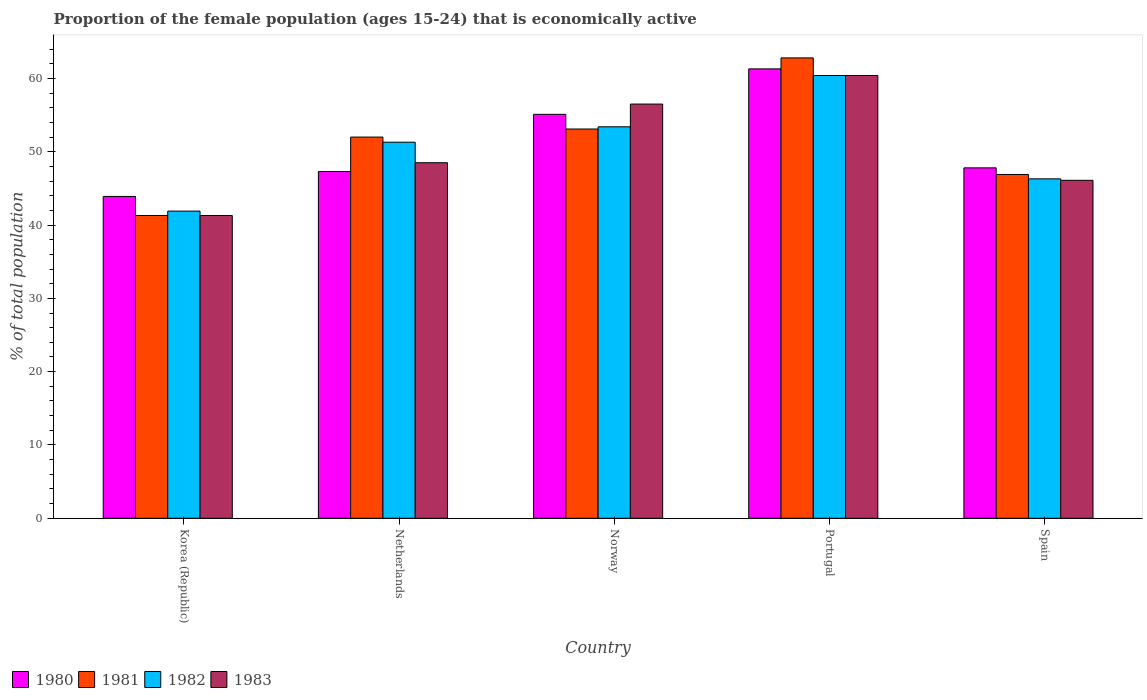How many different coloured bars are there?
Give a very brief answer. 4. Are the number of bars on each tick of the X-axis equal?
Your response must be concise. Yes. How many bars are there on the 2nd tick from the left?
Keep it short and to the point. 4. How many bars are there on the 2nd tick from the right?
Ensure brevity in your answer.  4. What is the label of the 1st group of bars from the left?
Provide a short and direct response. Korea (Republic). What is the proportion of the female population that is economically active in 1980 in Spain?
Your response must be concise. 47.8. Across all countries, what is the maximum proportion of the female population that is economically active in 1981?
Provide a succinct answer. 62.8. Across all countries, what is the minimum proportion of the female population that is economically active in 1980?
Provide a succinct answer. 43.9. In which country was the proportion of the female population that is economically active in 1980 maximum?
Offer a terse response. Portugal. What is the total proportion of the female population that is economically active in 1982 in the graph?
Offer a very short reply. 253.3. What is the difference between the proportion of the female population that is economically active in 1981 in Korea (Republic) and that in Portugal?
Ensure brevity in your answer.  -21.5. What is the difference between the proportion of the female population that is economically active in 1982 in Korea (Republic) and the proportion of the female population that is economically active in 1980 in Spain?
Offer a very short reply. -5.9. What is the average proportion of the female population that is economically active in 1980 per country?
Offer a very short reply. 51.08. What is the ratio of the proportion of the female population that is economically active in 1981 in Netherlands to that in Spain?
Provide a short and direct response. 1.11. Is the proportion of the female population that is economically active in 1982 in Korea (Republic) less than that in Spain?
Offer a terse response. Yes. What is the difference between the highest and the second highest proportion of the female population that is economically active in 1983?
Offer a very short reply. 8. What is the difference between the highest and the lowest proportion of the female population that is economically active in 1980?
Your response must be concise. 17.4. Is the sum of the proportion of the female population that is economically active in 1980 in Portugal and Spain greater than the maximum proportion of the female population that is economically active in 1982 across all countries?
Ensure brevity in your answer.  Yes. Is it the case that in every country, the sum of the proportion of the female population that is economically active in 1981 and proportion of the female population that is economically active in 1982 is greater than the sum of proportion of the female population that is economically active in 1980 and proportion of the female population that is economically active in 1983?
Offer a terse response. No. What does the 2nd bar from the right in Portugal represents?
Your response must be concise. 1982. Is it the case that in every country, the sum of the proportion of the female population that is economically active in 1981 and proportion of the female population that is economically active in 1980 is greater than the proportion of the female population that is economically active in 1983?
Ensure brevity in your answer.  Yes. Are all the bars in the graph horizontal?
Your response must be concise. No. How many countries are there in the graph?
Your response must be concise. 5. Where does the legend appear in the graph?
Provide a succinct answer. Bottom left. How many legend labels are there?
Your answer should be compact. 4. How are the legend labels stacked?
Provide a succinct answer. Horizontal. What is the title of the graph?
Your answer should be compact. Proportion of the female population (ages 15-24) that is economically active. Does "1985" appear as one of the legend labels in the graph?
Give a very brief answer. No. What is the label or title of the X-axis?
Provide a short and direct response. Country. What is the label or title of the Y-axis?
Offer a very short reply. % of total population. What is the % of total population of 1980 in Korea (Republic)?
Make the answer very short. 43.9. What is the % of total population in 1981 in Korea (Republic)?
Keep it short and to the point. 41.3. What is the % of total population in 1982 in Korea (Republic)?
Provide a succinct answer. 41.9. What is the % of total population in 1983 in Korea (Republic)?
Your response must be concise. 41.3. What is the % of total population of 1980 in Netherlands?
Provide a short and direct response. 47.3. What is the % of total population in 1982 in Netherlands?
Provide a succinct answer. 51.3. What is the % of total population in 1983 in Netherlands?
Your answer should be compact. 48.5. What is the % of total population of 1980 in Norway?
Your answer should be compact. 55.1. What is the % of total population in 1981 in Norway?
Ensure brevity in your answer.  53.1. What is the % of total population of 1982 in Norway?
Provide a short and direct response. 53.4. What is the % of total population of 1983 in Norway?
Provide a short and direct response. 56.5. What is the % of total population of 1980 in Portugal?
Ensure brevity in your answer.  61.3. What is the % of total population in 1981 in Portugal?
Your response must be concise. 62.8. What is the % of total population of 1982 in Portugal?
Your response must be concise. 60.4. What is the % of total population in 1983 in Portugal?
Make the answer very short. 60.4. What is the % of total population in 1980 in Spain?
Ensure brevity in your answer.  47.8. What is the % of total population of 1981 in Spain?
Provide a short and direct response. 46.9. What is the % of total population in 1982 in Spain?
Your response must be concise. 46.3. What is the % of total population of 1983 in Spain?
Make the answer very short. 46.1. Across all countries, what is the maximum % of total population in 1980?
Offer a very short reply. 61.3. Across all countries, what is the maximum % of total population in 1981?
Offer a terse response. 62.8. Across all countries, what is the maximum % of total population in 1982?
Give a very brief answer. 60.4. Across all countries, what is the maximum % of total population in 1983?
Ensure brevity in your answer.  60.4. Across all countries, what is the minimum % of total population of 1980?
Your answer should be compact. 43.9. Across all countries, what is the minimum % of total population of 1981?
Your answer should be very brief. 41.3. Across all countries, what is the minimum % of total population of 1982?
Provide a short and direct response. 41.9. Across all countries, what is the minimum % of total population of 1983?
Your answer should be very brief. 41.3. What is the total % of total population in 1980 in the graph?
Your answer should be very brief. 255.4. What is the total % of total population of 1981 in the graph?
Ensure brevity in your answer.  256.1. What is the total % of total population in 1982 in the graph?
Offer a terse response. 253.3. What is the total % of total population in 1983 in the graph?
Offer a very short reply. 252.8. What is the difference between the % of total population of 1982 in Korea (Republic) and that in Netherlands?
Keep it short and to the point. -9.4. What is the difference between the % of total population of 1980 in Korea (Republic) and that in Norway?
Make the answer very short. -11.2. What is the difference between the % of total population of 1981 in Korea (Republic) and that in Norway?
Make the answer very short. -11.8. What is the difference between the % of total population of 1983 in Korea (Republic) and that in Norway?
Offer a terse response. -15.2. What is the difference between the % of total population in 1980 in Korea (Republic) and that in Portugal?
Give a very brief answer. -17.4. What is the difference between the % of total population in 1981 in Korea (Republic) and that in Portugal?
Ensure brevity in your answer.  -21.5. What is the difference between the % of total population of 1982 in Korea (Republic) and that in Portugal?
Keep it short and to the point. -18.5. What is the difference between the % of total population of 1983 in Korea (Republic) and that in Portugal?
Ensure brevity in your answer.  -19.1. What is the difference between the % of total population of 1980 in Korea (Republic) and that in Spain?
Your answer should be very brief. -3.9. What is the difference between the % of total population of 1982 in Korea (Republic) and that in Spain?
Your answer should be compact. -4.4. What is the difference between the % of total population of 1983 in Netherlands and that in Norway?
Your answer should be very brief. -8. What is the difference between the % of total population of 1980 in Netherlands and that in Portugal?
Keep it short and to the point. -14. What is the difference between the % of total population in 1982 in Netherlands and that in Spain?
Provide a succinct answer. 5. What is the difference between the % of total population of 1983 in Netherlands and that in Spain?
Give a very brief answer. 2.4. What is the difference between the % of total population of 1981 in Norway and that in Portugal?
Provide a succinct answer. -9.7. What is the difference between the % of total population of 1982 in Norway and that in Portugal?
Provide a succinct answer. -7. What is the difference between the % of total population in 1983 in Norway and that in Portugal?
Give a very brief answer. -3.9. What is the difference between the % of total population in 1980 in Norway and that in Spain?
Give a very brief answer. 7.3. What is the difference between the % of total population in 1981 in Norway and that in Spain?
Give a very brief answer. 6.2. What is the difference between the % of total population in 1982 in Norway and that in Spain?
Offer a terse response. 7.1. What is the difference between the % of total population of 1983 in Norway and that in Spain?
Offer a terse response. 10.4. What is the difference between the % of total population of 1982 in Portugal and that in Spain?
Your answer should be very brief. 14.1. What is the difference between the % of total population of 1983 in Portugal and that in Spain?
Provide a short and direct response. 14.3. What is the difference between the % of total population of 1980 in Korea (Republic) and the % of total population of 1981 in Netherlands?
Keep it short and to the point. -8.1. What is the difference between the % of total population in 1980 in Korea (Republic) and the % of total population in 1982 in Netherlands?
Provide a succinct answer. -7.4. What is the difference between the % of total population in 1980 in Korea (Republic) and the % of total population in 1983 in Netherlands?
Offer a terse response. -4.6. What is the difference between the % of total population in 1981 in Korea (Republic) and the % of total population in 1983 in Netherlands?
Provide a succinct answer. -7.2. What is the difference between the % of total population in 1980 in Korea (Republic) and the % of total population in 1981 in Norway?
Offer a very short reply. -9.2. What is the difference between the % of total population in 1981 in Korea (Republic) and the % of total population in 1983 in Norway?
Offer a very short reply. -15.2. What is the difference between the % of total population in 1982 in Korea (Republic) and the % of total population in 1983 in Norway?
Offer a terse response. -14.6. What is the difference between the % of total population of 1980 in Korea (Republic) and the % of total population of 1981 in Portugal?
Provide a succinct answer. -18.9. What is the difference between the % of total population in 1980 in Korea (Republic) and the % of total population in 1982 in Portugal?
Provide a succinct answer. -16.5. What is the difference between the % of total population of 1980 in Korea (Republic) and the % of total population of 1983 in Portugal?
Your answer should be compact. -16.5. What is the difference between the % of total population of 1981 in Korea (Republic) and the % of total population of 1982 in Portugal?
Give a very brief answer. -19.1. What is the difference between the % of total population in 1981 in Korea (Republic) and the % of total population in 1983 in Portugal?
Offer a very short reply. -19.1. What is the difference between the % of total population in 1982 in Korea (Republic) and the % of total population in 1983 in Portugal?
Ensure brevity in your answer.  -18.5. What is the difference between the % of total population in 1980 in Korea (Republic) and the % of total population in 1982 in Spain?
Make the answer very short. -2.4. What is the difference between the % of total population in 1981 in Korea (Republic) and the % of total population in 1982 in Spain?
Provide a short and direct response. -5. What is the difference between the % of total population in 1982 in Korea (Republic) and the % of total population in 1983 in Spain?
Your answer should be compact. -4.2. What is the difference between the % of total population in 1980 in Netherlands and the % of total population in 1981 in Norway?
Provide a succinct answer. -5.8. What is the difference between the % of total population in 1980 in Netherlands and the % of total population in 1982 in Norway?
Your answer should be very brief. -6.1. What is the difference between the % of total population of 1981 in Netherlands and the % of total population of 1982 in Norway?
Your answer should be compact. -1.4. What is the difference between the % of total population of 1982 in Netherlands and the % of total population of 1983 in Norway?
Ensure brevity in your answer.  -5.2. What is the difference between the % of total population of 1980 in Netherlands and the % of total population of 1981 in Portugal?
Your answer should be very brief. -15.5. What is the difference between the % of total population in 1981 in Netherlands and the % of total population in 1982 in Portugal?
Provide a succinct answer. -8.4. What is the difference between the % of total population of 1981 in Netherlands and the % of total population of 1983 in Portugal?
Offer a very short reply. -8.4. What is the difference between the % of total population of 1982 in Netherlands and the % of total population of 1983 in Portugal?
Make the answer very short. -9.1. What is the difference between the % of total population of 1980 in Netherlands and the % of total population of 1981 in Spain?
Your response must be concise. 0.4. What is the difference between the % of total population in 1980 in Netherlands and the % of total population in 1982 in Spain?
Offer a terse response. 1. What is the difference between the % of total population in 1980 in Netherlands and the % of total population in 1983 in Spain?
Provide a short and direct response. 1.2. What is the difference between the % of total population of 1980 in Norway and the % of total population of 1981 in Portugal?
Offer a terse response. -7.7. What is the difference between the % of total population in 1980 in Norway and the % of total population in 1982 in Portugal?
Your answer should be compact. -5.3. What is the difference between the % of total population of 1980 in Norway and the % of total population of 1983 in Portugal?
Give a very brief answer. -5.3. What is the difference between the % of total population in 1982 in Norway and the % of total population in 1983 in Portugal?
Keep it short and to the point. -7. What is the difference between the % of total population in 1980 in Norway and the % of total population in 1981 in Spain?
Your answer should be compact. 8.2. What is the difference between the % of total population in 1982 in Norway and the % of total population in 1983 in Spain?
Offer a terse response. 7.3. What is the difference between the % of total population of 1980 in Portugal and the % of total population of 1982 in Spain?
Provide a succinct answer. 15. What is the average % of total population of 1980 per country?
Keep it short and to the point. 51.08. What is the average % of total population of 1981 per country?
Provide a short and direct response. 51.22. What is the average % of total population of 1982 per country?
Keep it short and to the point. 50.66. What is the average % of total population of 1983 per country?
Your answer should be compact. 50.56. What is the difference between the % of total population in 1980 and % of total population in 1983 in Korea (Republic)?
Ensure brevity in your answer.  2.6. What is the difference between the % of total population of 1981 and % of total population of 1983 in Korea (Republic)?
Your answer should be compact. 0. What is the difference between the % of total population in 1982 and % of total population in 1983 in Korea (Republic)?
Provide a short and direct response. 0.6. What is the difference between the % of total population of 1980 and % of total population of 1982 in Netherlands?
Give a very brief answer. -4. What is the difference between the % of total population of 1980 and % of total population of 1983 in Netherlands?
Your answer should be compact. -1.2. What is the difference between the % of total population in 1981 and % of total population in 1983 in Netherlands?
Offer a very short reply. 3.5. What is the difference between the % of total population in 1982 and % of total population in 1983 in Netherlands?
Your answer should be very brief. 2.8. What is the difference between the % of total population in 1980 and % of total population in 1982 in Norway?
Your response must be concise. 1.7. What is the difference between the % of total population of 1980 and % of total population of 1983 in Norway?
Give a very brief answer. -1.4. What is the difference between the % of total population in 1981 and % of total population in 1982 in Norway?
Your response must be concise. -0.3. What is the difference between the % of total population in 1981 and % of total population in 1983 in Norway?
Your response must be concise. -3.4. What is the difference between the % of total population of 1980 and % of total population of 1981 in Portugal?
Ensure brevity in your answer.  -1.5. What is the difference between the % of total population in 1980 and % of total population in 1982 in Portugal?
Ensure brevity in your answer.  0.9. What is the difference between the % of total population of 1980 and % of total population of 1983 in Portugal?
Your answer should be compact. 0.9. What is the difference between the % of total population of 1982 and % of total population of 1983 in Portugal?
Give a very brief answer. 0. What is the difference between the % of total population in 1980 and % of total population in 1981 in Spain?
Keep it short and to the point. 0.9. What is the difference between the % of total population of 1980 and % of total population of 1982 in Spain?
Give a very brief answer. 1.5. What is the difference between the % of total population in 1980 and % of total population in 1983 in Spain?
Offer a terse response. 1.7. What is the difference between the % of total population of 1981 and % of total population of 1983 in Spain?
Keep it short and to the point. 0.8. What is the ratio of the % of total population in 1980 in Korea (Republic) to that in Netherlands?
Your response must be concise. 0.93. What is the ratio of the % of total population of 1981 in Korea (Republic) to that in Netherlands?
Your response must be concise. 0.79. What is the ratio of the % of total population in 1982 in Korea (Republic) to that in Netherlands?
Your answer should be very brief. 0.82. What is the ratio of the % of total population of 1983 in Korea (Republic) to that in Netherlands?
Your answer should be very brief. 0.85. What is the ratio of the % of total population in 1980 in Korea (Republic) to that in Norway?
Give a very brief answer. 0.8. What is the ratio of the % of total population of 1982 in Korea (Republic) to that in Norway?
Your response must be concise. 0.78. What is the ratio of the % of total population of 1983 in Korea (Republic) to that in Norway?
Your answer should be compact. 0.73. What is the ratio of the % of total population in 1980 in Korea (Republic) to that in Portugal?
Keep it short and to the point. 0.72. What is the ratio of the % of total population of 1981 in Korea (Republic) to that in Portugal?
Offer a very short reply. 0.66. What is the ratio of the % of total population in 1982 in Korea (Republic) to that in Portugal?
Your answer should be very brief. 0.69. What is the ratio of the % of total population of 1983 in Korea (Republic) to that in Portugal?
Provide a succinct answer. 0.68. What is the ratio of the % of total population of 1980 in Korea (Republic) to that in Spain?
Provide a succinct answer. 0.92. What is the ratio of the % of total population of 1981 in Korea (Republic) to that in Spain?
Your answer should be compact. 0.88. What is the ratio of the % of total population of 1982 in Korea (Republic) to that in Spain?
Your answer should be very brief. 0.91. What is the ratio of the % of total population of 1983 in Korea (Republic) to that in Spain?
Ensure brevity in your answer.  0.9. What is the ratio of the % of total population in 1980 in Netherlands to that in Norway?
Keep it short and to the point. 0.86. What is the ratio of the % of total population in 1981 in Netherlands to that in Norway?
Provide a succinct answer. 0.98. What is the ratio of the % of total population in 1982 in Netherlands to that in Norway?
Your response must be concise. 0.96. What is the ratio of the % of total population of 1983 in Netherlands to that in Norway?
Give a very brief answer. 0.86. What is the ratio of the % of total population of 1980 in Netherlands to that in Portugal?
Your response must be concise. 0.77. What is the ratio of the % of total population of 1981 in Netherlands to that in Portugal?
Give a very brief answer. 0.83. What is the ratio of the % of total population in 1982 in Netherlands to that in Portugal?
Make the answer very short. 0.85. What is the ratio of the % of total population of 1983 in Netherlands to that in Portugal?
Ensure brevity in your answer.  0.8. What is the ratio of the % of total population of 1981 in Netherlands to that in Spain?
Your answer should be very brief. 1.11. What is the ratio of the % of total population in 1982 in Netherlands to that in Spain?
Give a very brief answer. 1.11. What is the ratio of the % of total population of 1983 in Netherlands to that in Spain?
Keep it short and to the point. 1.05. What is the ratio of the % of total population in 1980 in Norway to that in Portugal?
Your answer should be very brief. 0.9. What is the ratio of the % of total population of 1981 in Norway to that in Portugal?
Offer a terse response. 0.85. What is the ratio of the % of total population in 1982 in Norway to that in Portugal?
Keep it short and to the point. 0.88. What is the ratio of the % of total population of 1983 in Norway to that in Portugal?
Your answer should be compact. 0.94. What is the ratio of the % of total population of 1980 in Norway to that in Spain?
Offer a terse response. 1.15. What is the ratio of the % of total population in 1981 in Norway to that in Spain?
Provide a succinct answer. 1.13. What is the ratio of the % of total population in 1982 in Norway to that in Spain?
Ensure brevity in your answer.  1.15. What is the ratio of the % of total population in 1983 in Norway to that in Spain?
Ensure brevity in your answer.  1.23. What is the ratio of the % of total population of 1980 in Portugal to that in Spain?
Your answer should be compact. 1.28. What is the ratio of the % of total population of 1981 in Portugal to that in Spain?
Ensure brevity in your answer.  1.34. What is the ratio of the % of total population in 1982 in Portugal to that in Spain?
Make the answer very short. 1.3. What is the ratio of the % of total population of 1983 in Portugal to that in Spain?
Offer a very short reply. 1.31. What is the difference between the highest and the second highest % of total population of 1980?
Your answer should be very brief. 6.2. What is the difference between the highest and the second highest % of total population of 1982?
Keep it short and to the point. 7. What is the difference between the highest and the lowest % of total population in 1980?
Your answer should be very brief. 17.4. What is the difference between the highest and the lowest % of total population of 1981?
Your answer should be compact. 21.5. 